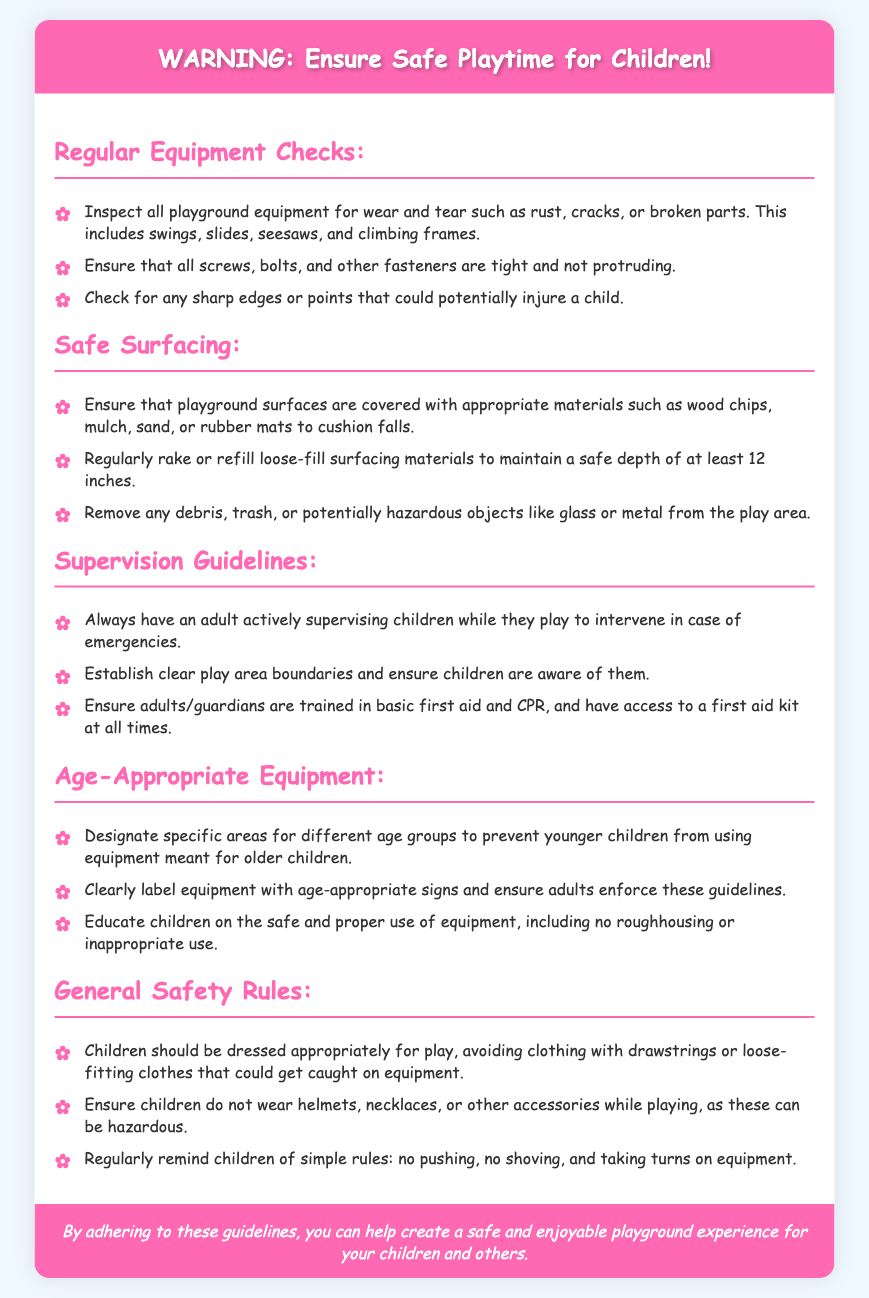what should be checked for wear and tear? The document lists swings, slides, seesaws, and climbing frames as playground equipment that should be checked for wear and tear.
Answer: swings, slides, seesaws, climbing frames what is the safe depth of loose-fill surfacing materials? The document specifies that loose-fill surfacing materials should maintain a safe depth of at least 12 inches.
Answer: 12 inches who should supervise children while they play? It is stated that an adult should always be actively supervising children while they play.
Answer: an adult what materials should playground surfaces be covered with? The document mentions wood chips, mulch, sand, or rubber mats as appropriate materials for playground surfaces.
Answer: wood chips, mulch, sand, rubber mats how should age groups be managed in playgrounds? The document advises designating specific areas for different age groups to prevent younger children from using equipment meant for older children.
Answer: specific areas for different age groups why is it important to educate children about equipment use? The document emphasizes educating children on the safe and proper use of equipment to prevent roughhousing or inappropriate use.
Answer: to prevent roughhousing or inappropriate use what should be available to adults supervising children? The document suggests that adults/guardians should have access to a first aid kit at all times.
Answer: a first aid kit what type of clothing should children avoid wearing? The document states that children should avoid clothing with drawstrings or loose-fitting clothes that could get caught on equipment.
Answer: clothing with drawstrings or loose-fitting clothes 